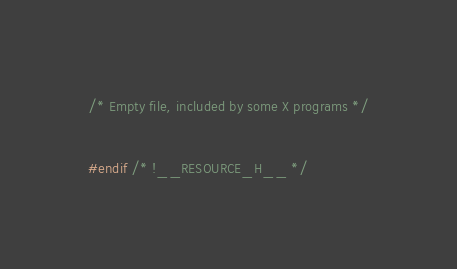Convert code to text. <code><loc_0><loc_0><loc_500><loc_500><_C_>/* Empty file, included by some X programs */

#endif /* !__RESOURCE_H__ */
</code> 